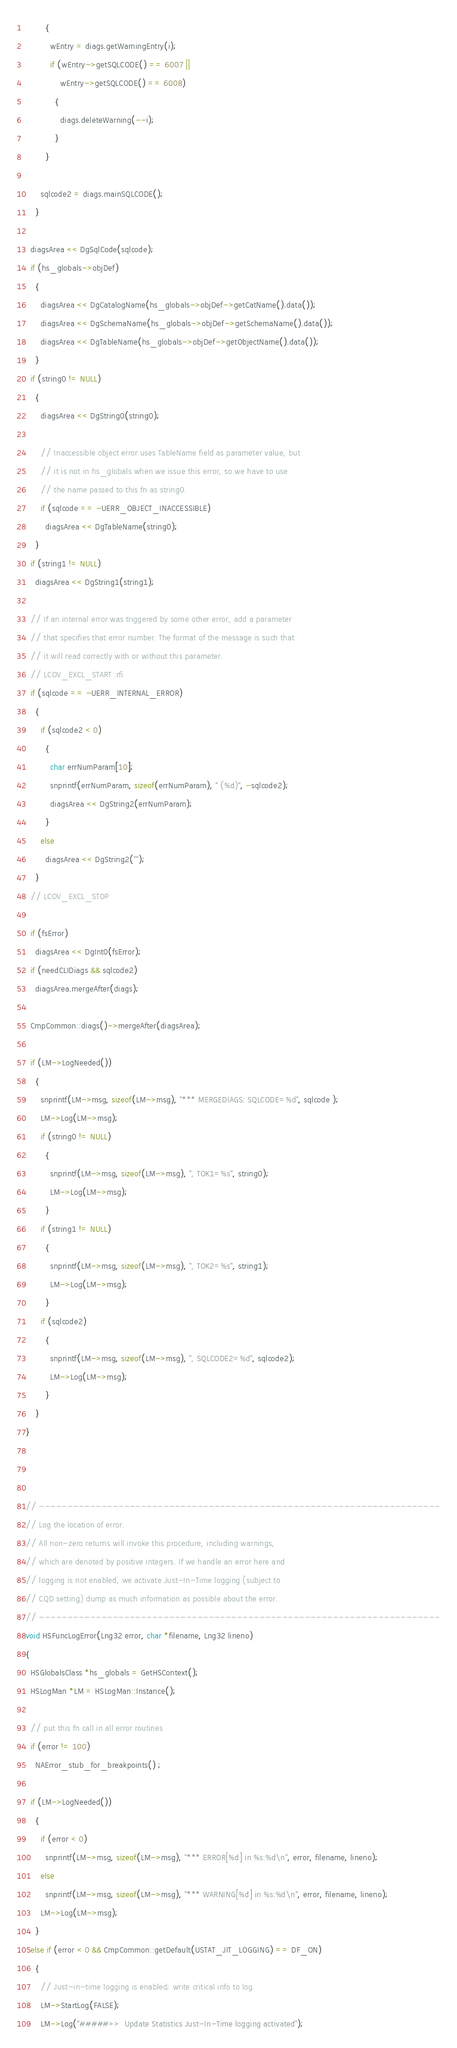Convert code to text. <code><loc_0><loc_0><loc_500><loc_500><_C++_>        {
          wEntry = diags.getWarningEntry(i);
          if (wEntry->getSQLCODE() == 6007 ||
              wEntry->getSQLCODE() == 6008)
            {
              diags.deleteWarning(--i);
            }
        }

      sqlcode2 = diags.mainSQLCODE();
    }

  diagsArea << DgSqlCode(sqlcode);
  if (hs_globals->objDef)
    {
      diagsArea << DgCatalogName(hs_globals->objDef->getCatName().data());
      diagsArea << DgSchemaName(hs_globals->objDef->getSchemaName().data());
      diagsArea << DgTableName(hs_globals->objDef->getObjectName().data());
    }
  if (string0 != NULL)
    {
      diagsArea << DgString0(string0);
      
      // Inaccessible object error uses TableName field as parameter value, but
      // it is not in hs_globals when we issue this error, so we have to use
      // the name passed to this fn as string0.
      if (sqlcode == -UERR_OBJECT_INACCESSIBLE)
        diagsArea << DgTableName(string0);
    }
  if (string1 != NULL)
    diagsArea << DgString1(string1);
    
  // If an internal error was triggered by some other error, add a parameter
  // that specifies that error number. The format of the message is such that
  // it will read correctly with or without this parameter.
  // LCOV_EXCL_START :rfi
  if (sqlcode == -UERR_INTERNAL_ERROR)
    {
      if (sqlcode2 < 0)
        {
          char errNumParam[10];
          snprintf(errNumParam, sizeof(errNumParam), " (%d)", -sqlcode2);
          diagsArea << DgString2(errNumParam);
        }
      else
        diagsArea << DgString2("");
    }
  // LCOV_EXCL_STOP
    
  if (fsError)
    diagsArea << DgInt0(fsError);
  if (needCLIDiags && sqlcode2)
    diagsArea.mergeAfter(diags);

  CmpCommon::diags()->mergeAfter(diagsArea);

  if (LM->LogNeeded())
    {
      snprintf(LM->msg, sizeof(LM->msg), "*** MERGEDIAGS: SQLCODE=%d", sqlcode );
      LM->Log(LM->msg);
      if (string0 != NULL)
        {
          snprintf(LM->msg, sizeof(LM->msg), ", TOK1=%s", string0);
          LM->Log(LM->msg);
        }
      if (string1 != NULL)
        {
          snprintf(LM->msg, sizeof(LM->msg), ", TOK2=%s", string1);
          LM->Log(LM->msg);
        }
      if (sqlcode2)
        {
          snprintf(LM->msg, sizeof(LM->msg), ", SQLCODE2=%d", sqlcode2);
          LM->Log(LM->msg);
        }
    }
}



// -----------------------------------------------------------------------
// Log the location of error.
// All non-zero returns will invoke this procedure, including warnings,
// which are denoted by positive integers. If we handle an error here and
// logging is not enabled, we activate Just-In-Time logging (subject to
// CQD setting) dump as much information as possible about the error.
// -----------------------------------------------------------------------
void HSFuncLogError(Lng32 error, char *filename, Lng32 lineno)
{
  HSGlobalsClass *hs_globals = GetHSContext();
  HSLogMan *LM = HSLogMan::Instance();

  // put this fn call in all error routines
  if (error != 100)
    NAError_stub_for_breakpoints() ;

  if (LM->LogNeeded())
    {
      if (error < 0)
        snprintf(LM->msg, sizeof(LM->msg), "*** ERROR[%d] in %s:%d\n", error, filename, lineno);
      else
        snprintf(LM->msg, sizeof(LM->msg), "*** WARNING[%d] in %s:%d\n", error, filename, lineno);
      LM->Log(LM->msg);
    }
  else if (error < 0 && CmpCommon::getDefault(USTAT_JIT_LOGGING) == DF_ON)
    {
      // Just-in-time logging is enabled; write critical info to log.
      LM->StartLog(FALSE);
      LM->Log("#####>>  Update Statistics Just-In-Time logging activated");</code> 